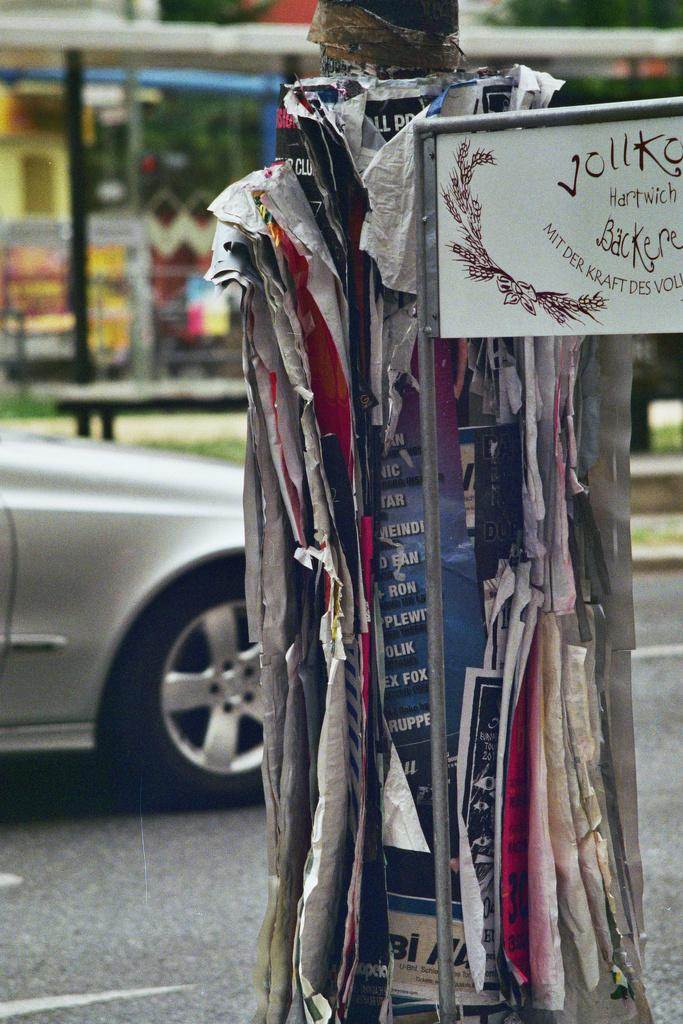What is attached to the pole in the image? There are posters attached to a pole in the image. What can be found on the board in the image? There is a board with text in the image. What is present on the road in the image? There is a vehicle on the road in the image. What type of structure is visible in the image? There is a building in the image. What type of stone is being digested by the party in the image? There is no party or stone present in the image. How does the digestion process affect the posters on the pole? The posters on the pole are not affected by any digestion process, as they are not living organisms. 